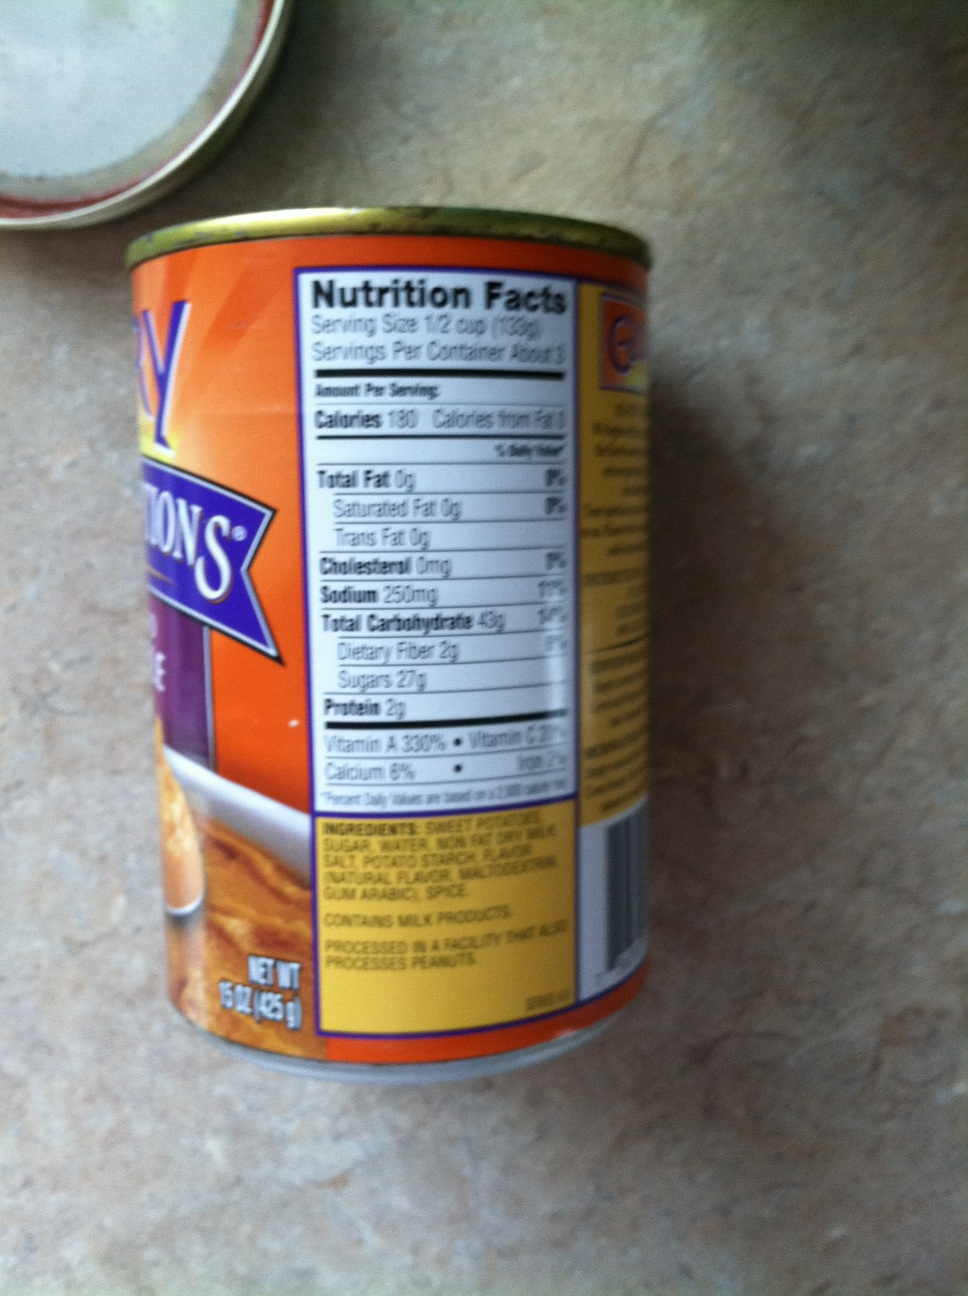Can you tell me what this is a tin of? This tin appears to be a can of sweet potatoes. The label indicates that it contains sweet potatoes along with other ingredients like sugar, water, and spices. 